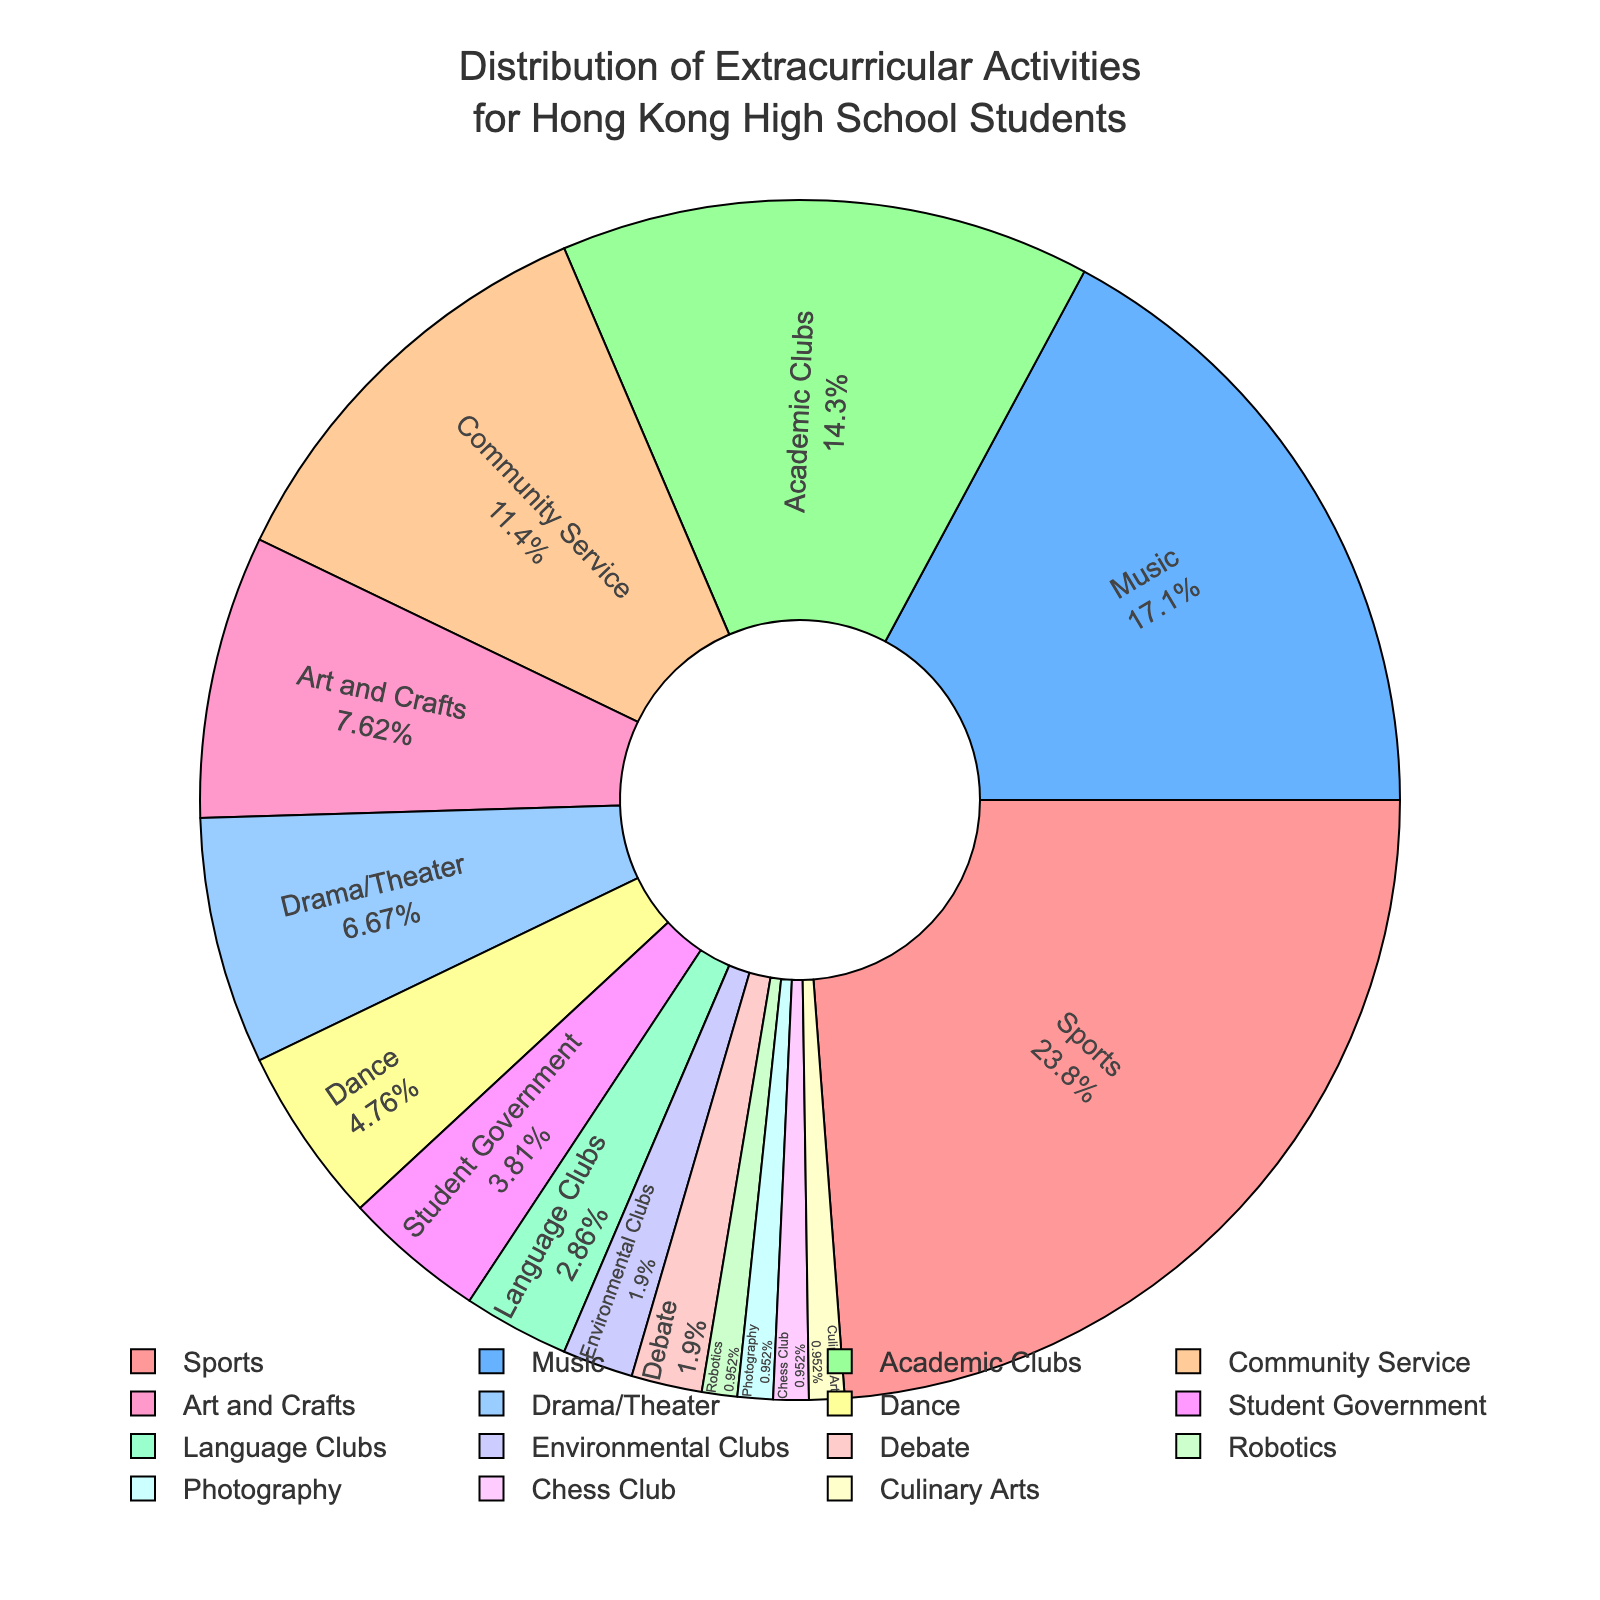What activity has the highest percentage? Look at the pie chart for the activity with the largest slice. "Sports" has the largest portion, corresponding to 25%.
Answer: Sports How many activities have a percentage greater than or equal to 10%? Count the slices on the pie chart that have labels showing 10% or more. There are four activities: Sports (25%), Music (18%), Academic Clubs (15%), and Community Service (12%).
Answer: 4 What is the combined percentage of Music, Drama/Theater, and Dance activities? Add the percentages of Music (18%), Drama/Theater (7%), and Dance (5%). 18% + 7% + 5% equals 30%.
Answer: 30% Which activity has the smallest percentage? The smallest slice on the pie chart corresponds to the activities with 1%. There are five activities: Robotics, Photography, Chess Club, and Culinary Arts. Any of these can be considered the correct answer.
Answer: Robotics / Photography / Chess Club / Culinary Arts Is Community Service participation more than double that for Student Government? Community Service has 12% participation. For Student Government to be less than half of that, it would need to be less than 6%. Student Government has 4%, which is indeed less than half of 12%.
Answer: Yes What is the difference in percentage between the highest activity and the lowest activity? The highest percentage is for Sports at 25%, and the lowest percentage is for several activities at 1%. The difference is 25% - 1%, which is 24%.
Answer: 24% Which activities have a combined percentage equal to that of Music? Look for combinations of activities that sum to 18% (the percentage for Music). One such combination is Drama/Theater (7%) and Dance (5%) and Robotics (1%) and Photography (1%) and Chess Club (1%) and Culinary Arts (1%), which together total 18%.
Answer: Drama/Theater, Dance, Robotics, Photography, Chess Club, Culinary Arts How does the percentage of Art and Crafts compare to Environmental Clubs? Art and Crafts have 8%, whereas Environmental Clubs have 2%. Art and Crafts has a higher percentage. 8% is 4 times greater than 2%.
Answer: 4 times greater If we combine the percentages of Language Clubs and Chess Club, do we get more than Student Government? Language Clubs have 3% and Chess Club has 1%, which sums to 4%. Student Government also has 4%. So, combining Language Clubs and Chess Club equals Student Government.
Answer: Equal Are there more students participating in Academic Clubs or Drama/Theater? Compare the percent values of these two activities: Academic Clubs have 15%, while Drama/Theater has 7%. Therefore, more students participate in Academic Clubs.
Answer: Academic Clubs 